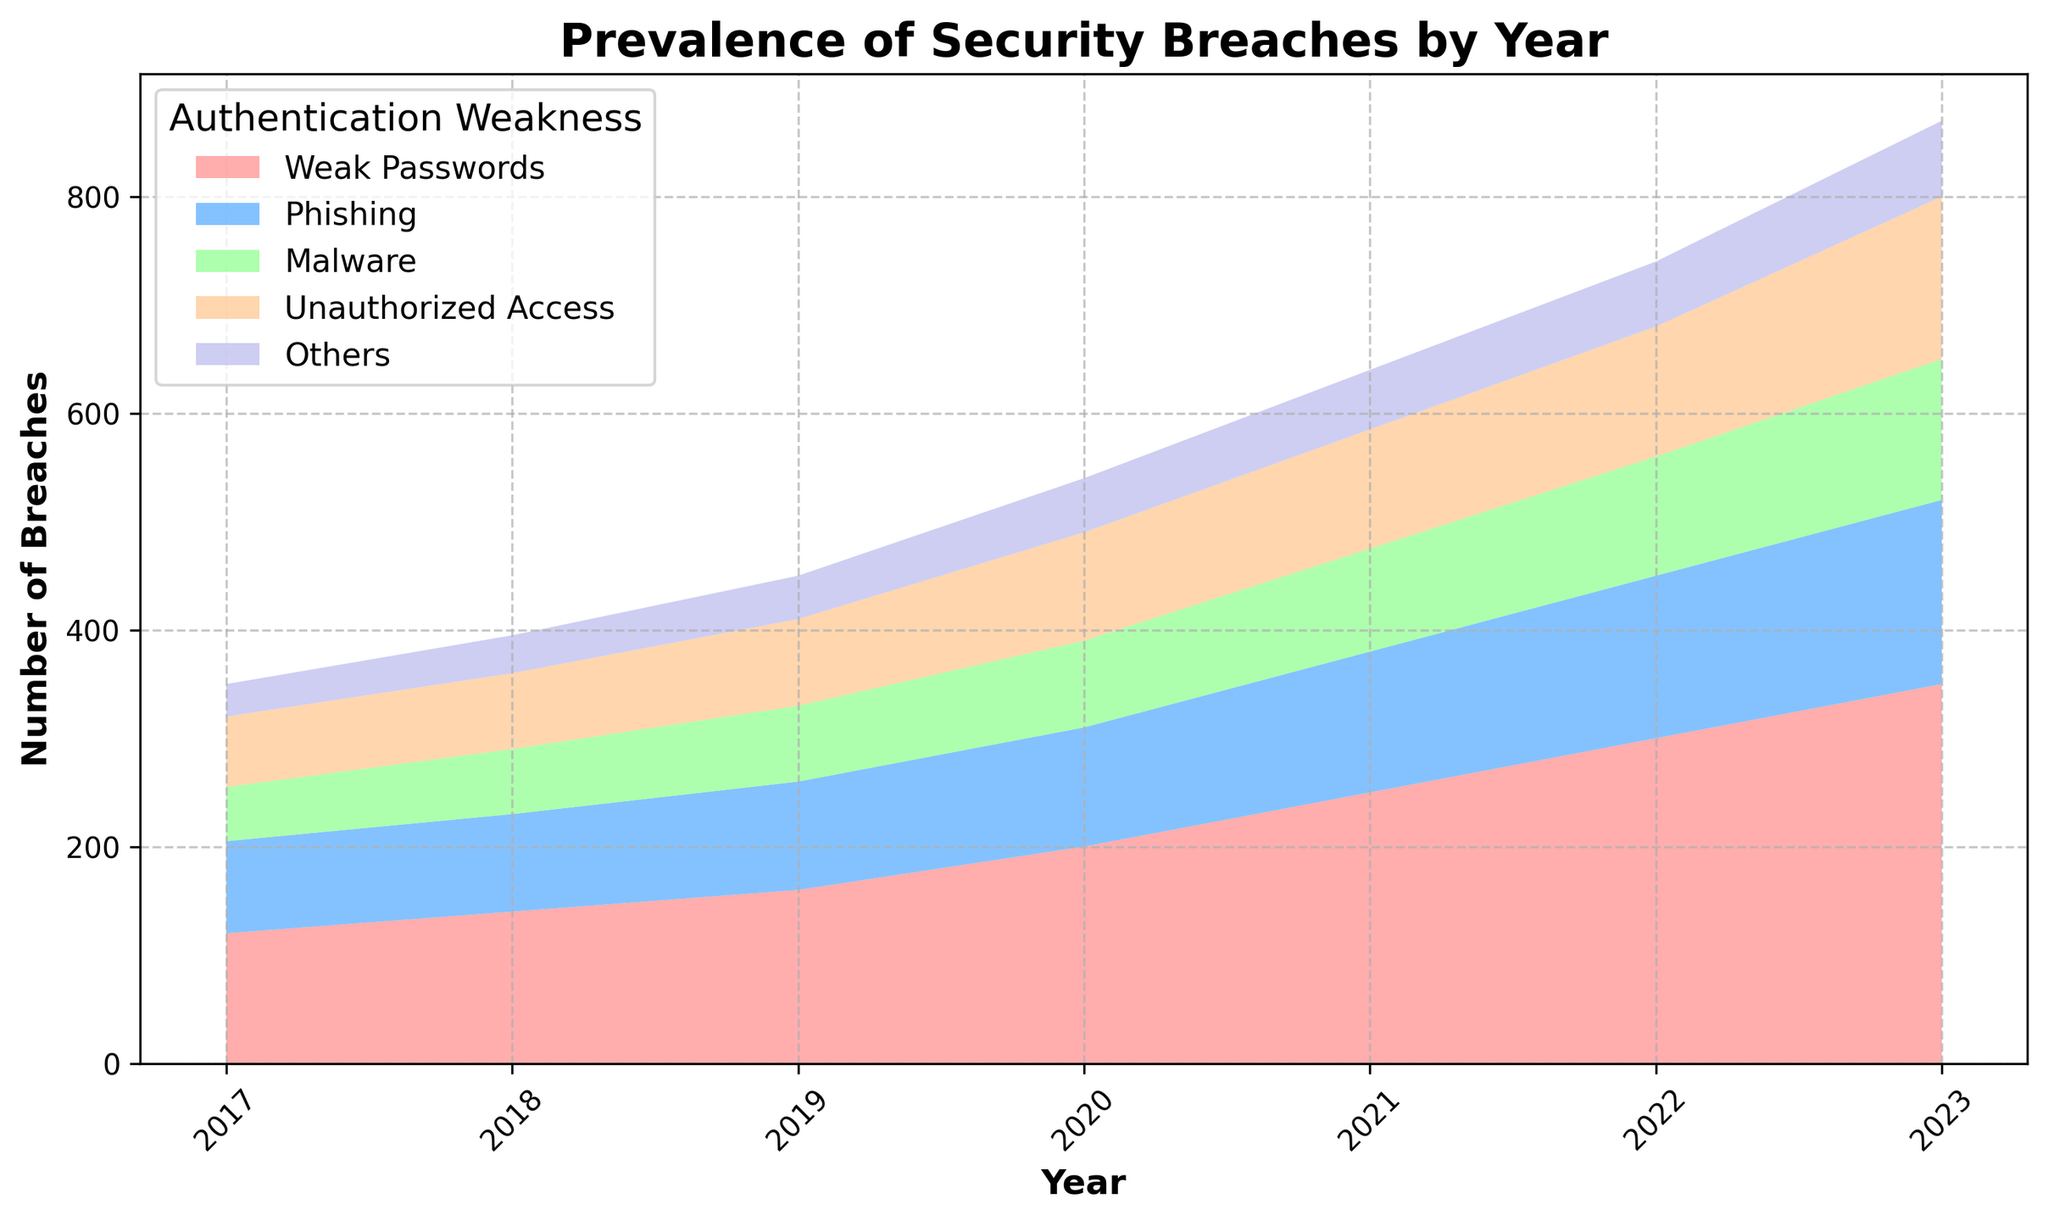How has the number of breaches due to phishing changed from 2017 to 2023? By observing the plot, we can see the area representing phishing in each year. In 2017, there were 85 breaches due to phishing, and this increased to 170 breaches by 2023.
Answer: Increased by 85 Which authentication weakness saw the largest increase in breaches from 2017 to 2023? By comparing the heights of the different colored areas, we see that weak passwords increased from 120 breaches in 2017 to 350 breaches in 2023, which is the largest increase among all the weaknesses.
Answer: Weak passwords What is the combined number of breaches due to malware and unauthorized access in 2022? The number of breaches due to malware in 2022 is 110, and the number due to unauthorized access is 120. Adding these gives 110 + 120 = 230.
Answer: 230 In which year did breaches due to weak passwords first surpass 200? By looking at the plot, we can observe that in 2020 the breaches due to weak passwords (represented in a specific color) exceeded 200 for the first time.
Answer: 2020 How does the trend of breaches due to phishing compare to that of unauthorized access from 2017 to 2023? Visually, both the phishing and unauthorized access areas have increased over the years, but phishing consistently showed a higher number of breaches than unauthorized access.
Answer: Phishing consistently higher What is the average number of breaches due to malware over the years presented? The numbers for malware breaches over the years are 50, 60, 70, 80, 95, 110, and 130. Summing these up, we get 50 + 60 + 70 + 80 + 95 + 110 + 130 = 595. There are 7 years, so the average is 595 / 7 ≈ 85.
Answer: 85 Which year recorded the lowest total number of breaches? By visually inspecting the heights of the stacked areas, the year 2017 has the lowest total height. Summing the breaches: 120 + 85 + 50 + 65 + 30 = 350. This is lower compared to the other years.
Answer: 2017 In 2021, which two authentication weaknesses together represented more breaches than weak passwords alone? In 2021, weak passwords account for 250 breaches. Phishing and malware together account for 130 + 95 = 225, which is less than 250. But phishing and unauthorized access together account for 130 + 110 = 240, which still is less. Therefore, weak passwords alone represented more breaches than any two other weaknesses combined.
Answer: None What are the differences in the counts of breaches between weak passwords and others in 2023? The counts of breaches in 2023 are 350 for weak passwords and 70 for others. The difference is 350 - 70 = 280.
Answer: 280 